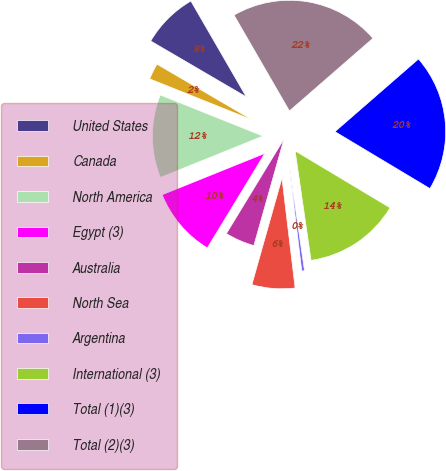<chart> <loc_0><loc_0><loc_500><loc_500><pie_chart><fcel>United States<fcel>Canada<fcel>North America<fcel>Egypt (3)<fcel>Australia<fcel>North Sea<fcel>Argentina<fcel>International (3)<fcel>Total (1)(3)<fcel>Total (2)(3)<nl><fcel>8.24%<fcel>2.36%<fcel>12.16%<fcel>10.2%<fcel>4.32%<fcel>6.28%<fcel>0.4%<fcel>14.11%<fcel>19.99%<fcel>21.95%<nl></chart> 